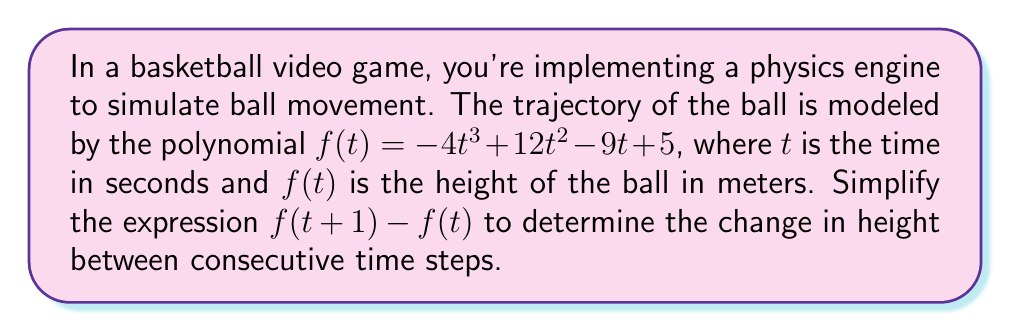Show me your answer to this math problem. Let's approach this step-by-step:

1) First, we need to calculate $f(t+1)$:
   $$f(t+1) = -4(t+1)^3 + 12(t+1)^2 - 9(t+1) + 5$$

2) Expand $(t+1)^3$ and $(t+1)^2$:
   $$f(t+1) = -4(t^3 + 3t^2 + 3t + 1) + 12(t^2 + 2t + 1) - 9t - 9 + 5$$

3) Multiply out the terms:
   $$f(t+1) = -4t^3 - 12t^2 - 12t - 4 + 12t^2 + 24t + 12 - 9t - 9 + 5$$

4) Simplify:
   $$f(t+1) = -4t^3 + 3t + 4$$

5) Now we have $f(t+1)$ and $f(t)$. Let's subtract:
   $$f(t+1) - f(t) = (-4t^3 + 3t + 4) - (-4t^3 + 12t^2 - 9t + 5)$$

6) Distribute the negative sign:
   $$f(t+1) - f(t) = -4t^3 + 3t + 4 + 4t^3 - 12t^2 + 9t - 5$$

7) Simplify by combining like terms:
   $$f(t+1) - f(t) = -12t^2 + 12t - 1$$

This simplified expression represents the change in height of the ball between consecutive time steps in the game's physics simulation.
Answer: $-12t^2 + 12t - 1$ 